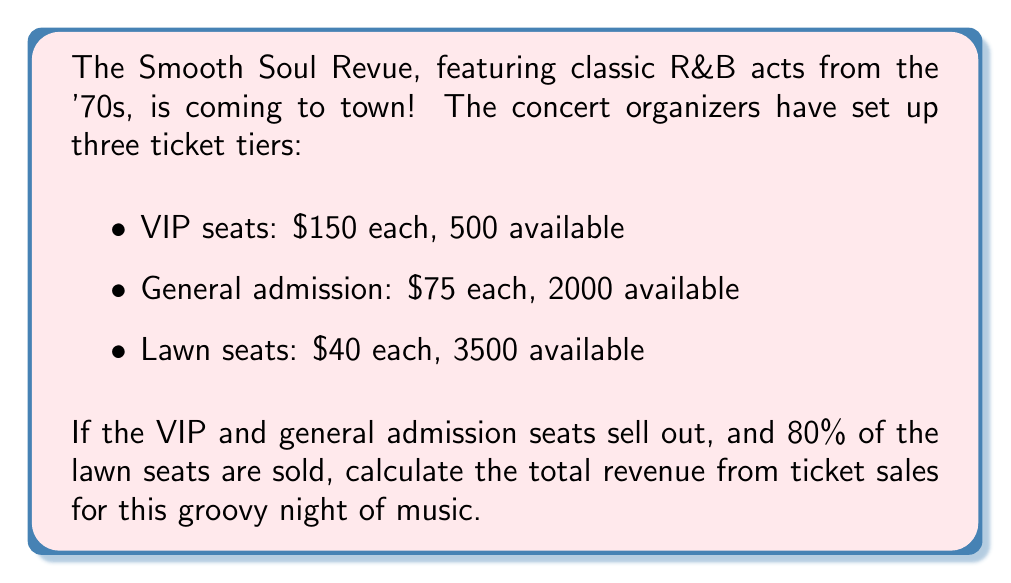What is the answer to this math problem? Let's break this down step-by-step:

1. Calculate the revenue from VIP seats:
   $$ \text{VIP Revenue} = 500 \text{ seats} \times \$150 = \$75,000 $$

2. Calculate the revenue from general admission:
   $$ \text{General Admission Revenue} = 2000 \text{ seats} \times \$75 = \$150,000 $$

3. Calculate the number of lawn seats sold:
   $$ \text{Lawn Seats Sold} = 3500 \text{ seats} \times 80\% = 3500 \times 0.8 = 2800 \text{ seats} $$

4. Calculate the revenue from lawn seats:
   $$ \text{Lawn Revenue} = 2800 \text{ seats} \times \$40 = \$112,000 $$

5. Sum up the total revenue:
   $$ \text{Total Revenue} = \text{VIP Revenue} + \text{General Admission Revenue} + \text{Lawn Revenue} $$
   $$ \text{Total Revenue} = \$75,000 + \$150,000 + \$112,000 = \$337,000 $$
Answer: $337,000 